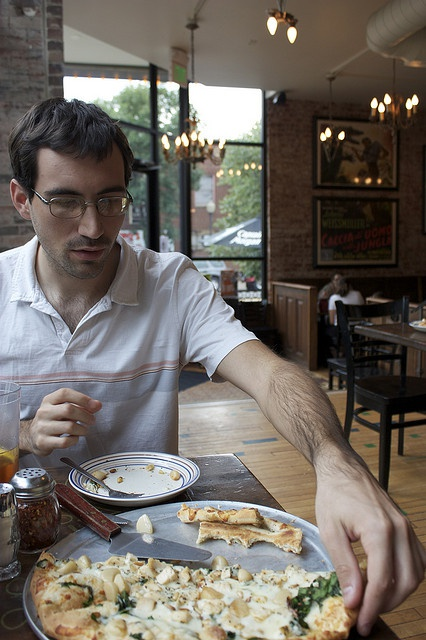Describe the objects in this image and their specific colors. I can see people in black, gray, darkgray, and lightgray tones, dining table in black, darkgray, gray, and lightgray tones, pizza in black, lightgray, beige, darkgray, and tan tones, chair in black and gray tones, and knife in black, gray, and maroon tones in this image. 